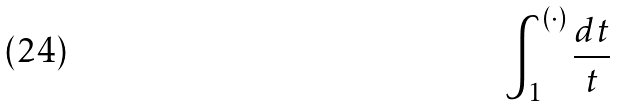Convert formula to latex. <formula><loc_0><loc_0><loc_500><loc_500>\int _ { 1 } ^ { ( \cdot ) } \frac { d t } { t }</formula> 